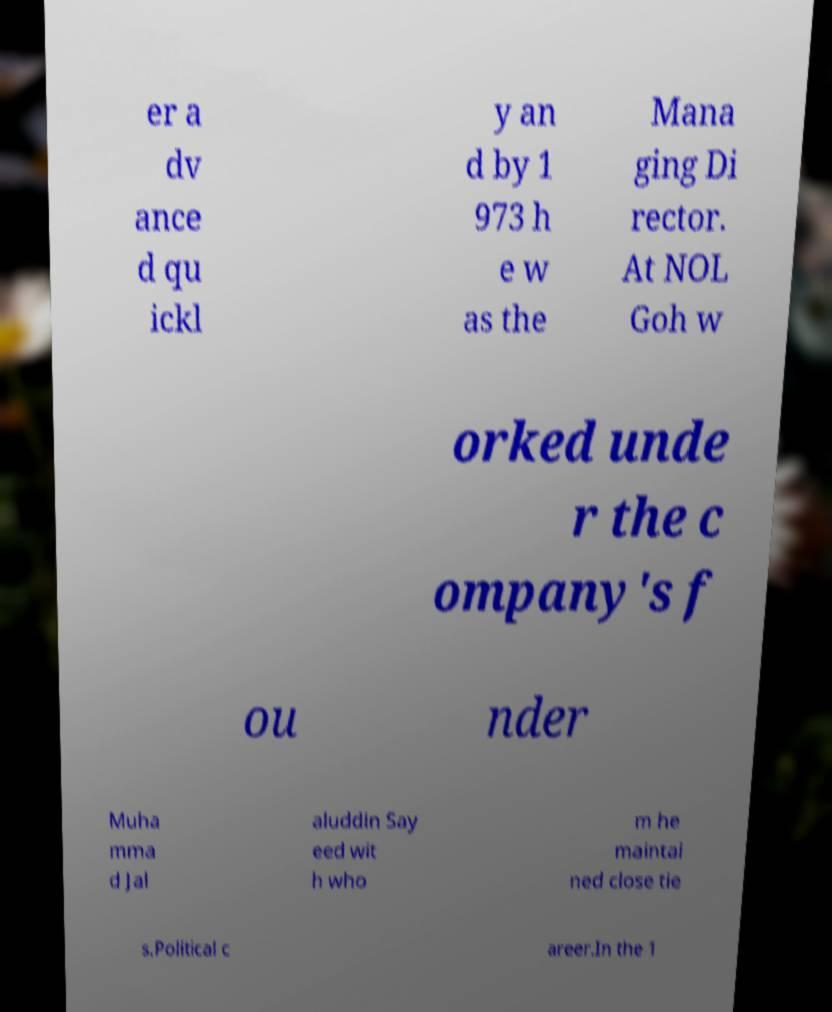For documentation purposes, I need the text within this image transcribed. Could you provide that? er a dv ance d qu ickl y an d by 1 973 h e w as the Mana ging Di rector. At NOL Goh w orked unde r the c ompany's f ou nder Muha mma d Jal aluddin Say eed wit h who m he maintai ned close tie s.Political c areer.In the 1 